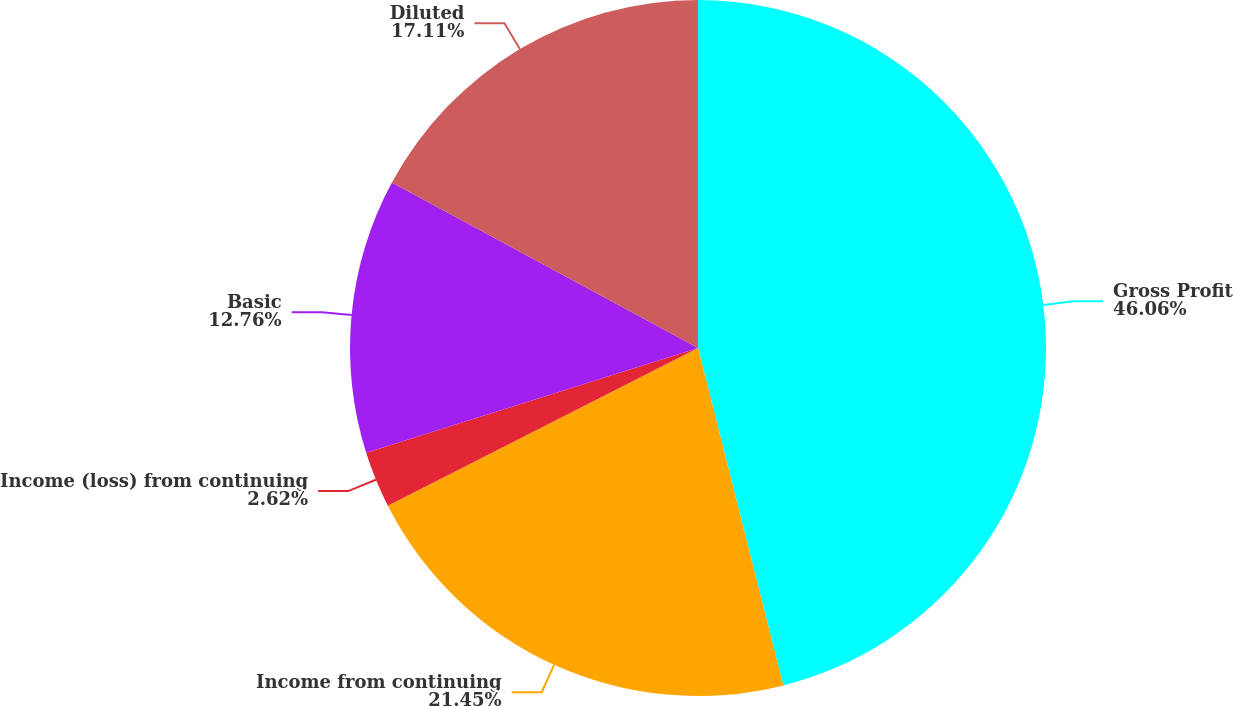<chart> <loc_0><loc_0><loc_500><loc_500><pie_chart><fcel>Gross Profit<fcel>Income from continuing<fcel>Income (loss) from continuing<fcel>Basic<fcel>Diluted<nl><fcel>46.06%<fcel>21.45%<fcel>2.62%<fcel>12.76%<fcel>17.11%<nl></chart> 